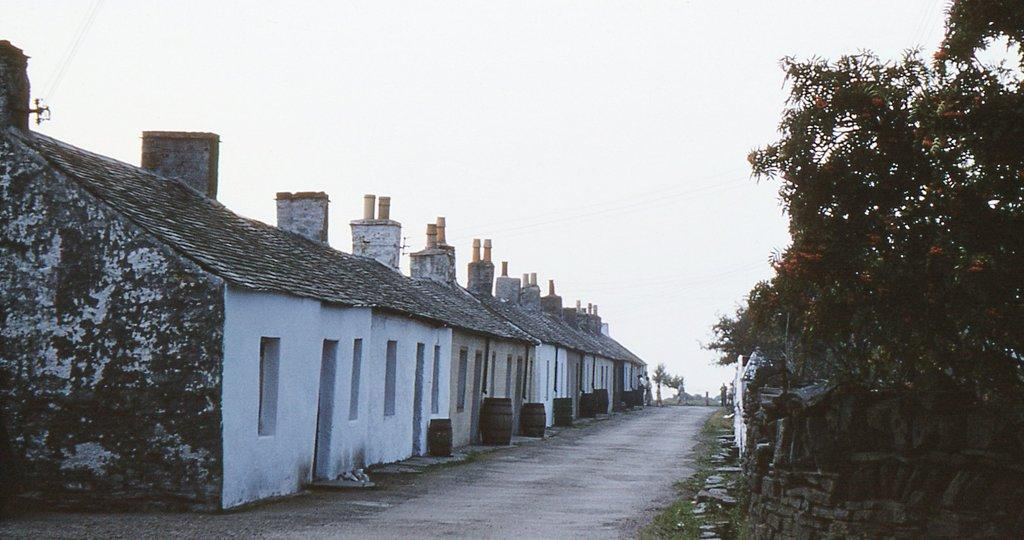What type of structures can be seen in the image? There are houses in the image. What objects are present that can hold or store items? There are containers in the image. What type of natural elements are visible in the image? There are trees and plants in the image. Can you describe any other elements in the image besides the ones mentioned? There are other unspecified things in the image. How much coal is visible in the image? There is no coal present in the image. What type of mint is growing among the plants in the image? There is no mint visible in the image; only plants are mentioned. 